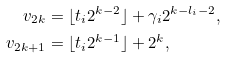<formula> <loc_0><loc_0><loc_500><loc_500>v _ { 2 k } & = \lfloor t _ { i } 2 ^ { k - 2 } \rfloor + \gamma _ { i } 2 ^ { k - l _ { i } - 2 } , \\ v _ { 2 k + 1 } & = \lfloor t _ { i } 2 ^ { k - 1 } \rfloor + 2 ^ { k } ,</formula> 